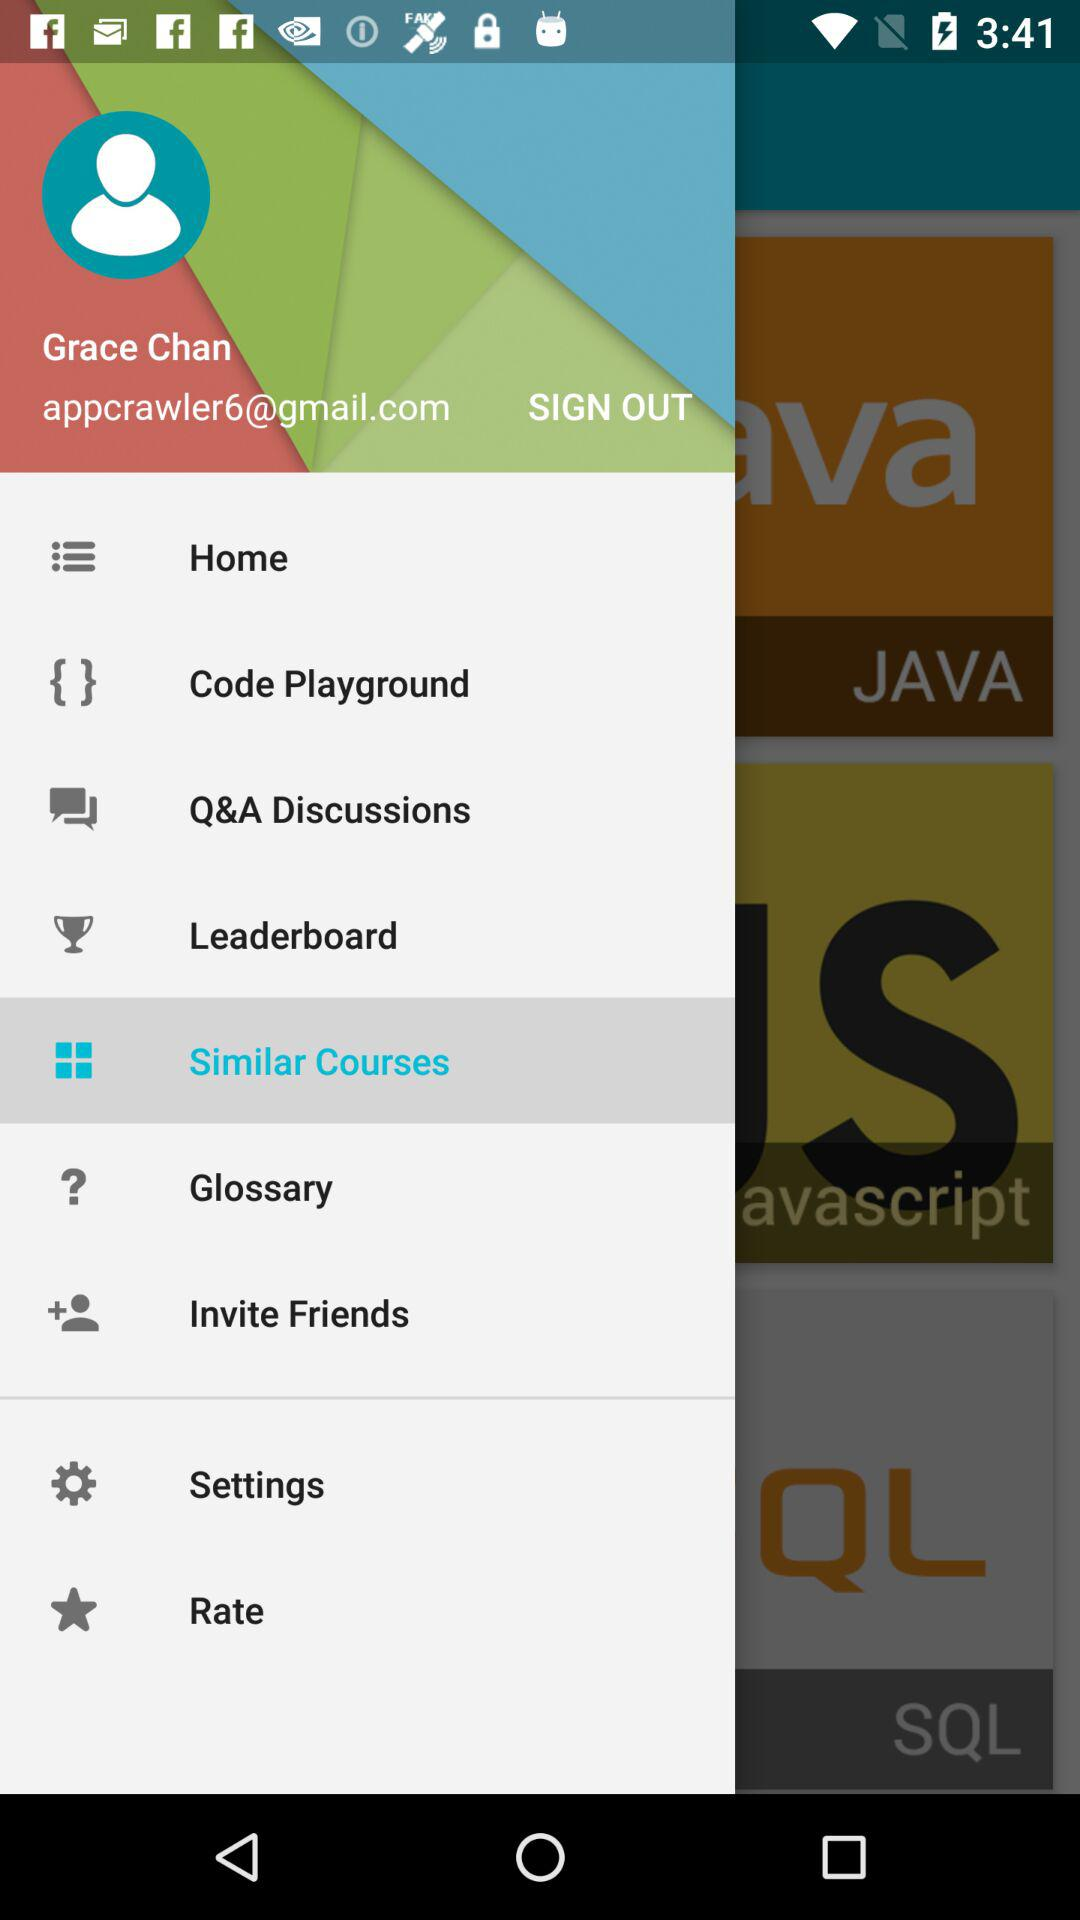What is the given user name? The given user name is Grace Chan. 